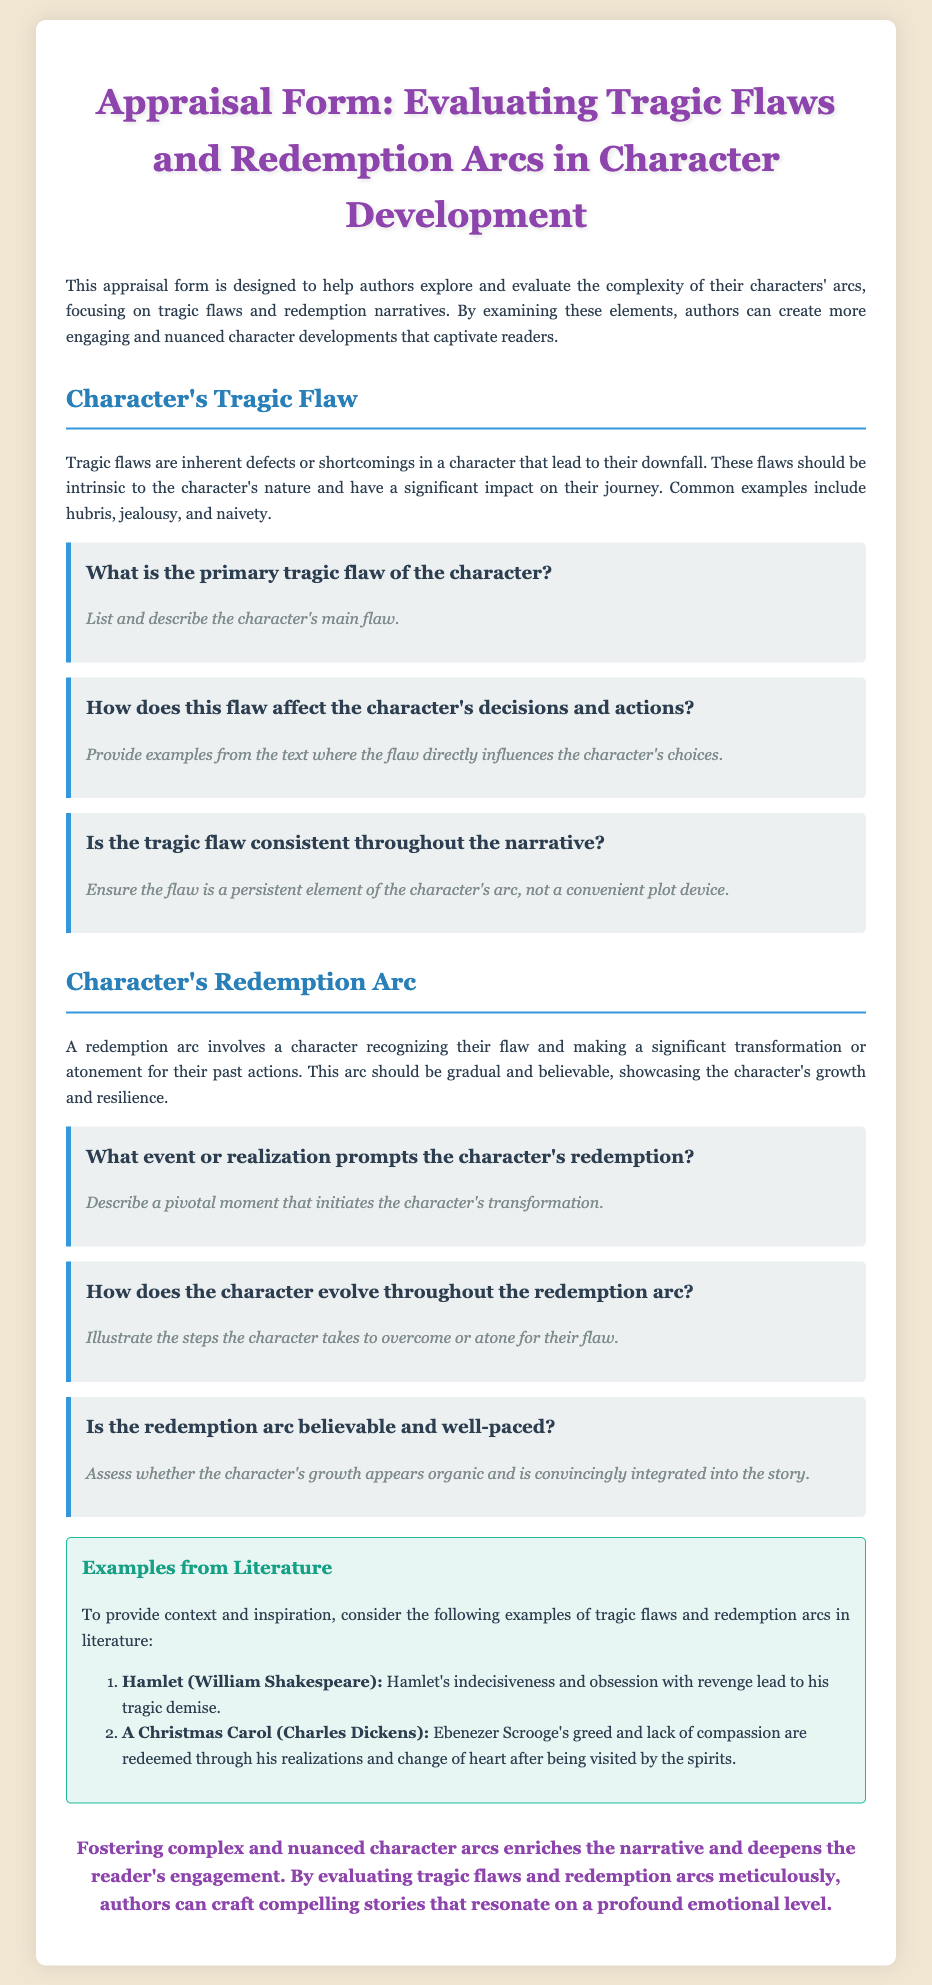What is the title of the document? The title can be found in the header of the document.
Answer: Appraisal Form: Evaluating Tragic Flaws and Redemption Arcs in Character Development What is the primary focus of this appraisal form? The primary focus is mentioned in the introductory paragraph.
Answer: Complexity of characters' arcs What are common examples of tragic flaws mentioned in the document? These examples are listed under the section describing tragic flaws.
Answer: Hubris, jealousy, naivety What is the purpose of a redemption arc? The purpose is explained in the section discussing redemption arcs.
Answer: Transformation or atonement for past actions Which character from literature exemplifies greed and later changes? The character is used as an example in the literature section.
Answer: Ebenezer Scrooge What does the prompt for the primary tragic flaw ask for? The prompt asks for specific information about the character's flaw.
Answer: List and describe the character's main flaw Is there a specific section dedicated to examples from literature? This information can be found in the document's structure.
Answer: Yes How many questions are posed about the tragic flaw? Count the questions listed under the tragic flaw section.
Answer: Three How does the document suggest authors can enrich their narratives? The conclusion provides insight into this suggestion.
Answer: By evaluating tragic flaws and redemption arcs meticulously 